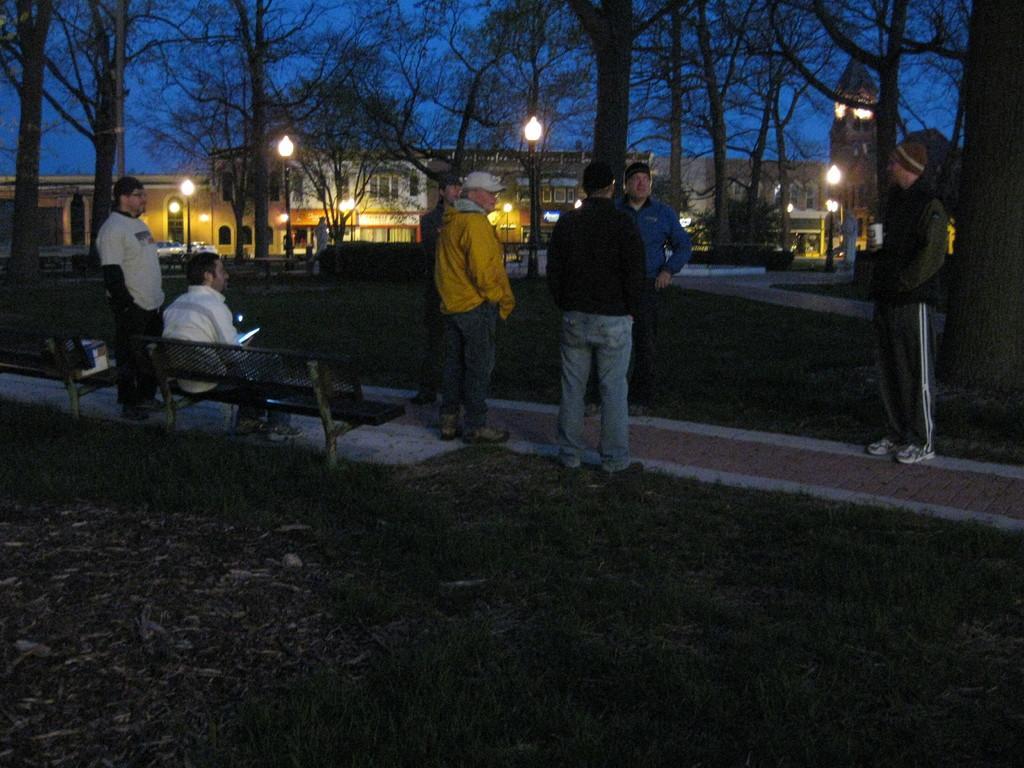Can you describe this image briefly? This is an image clicked in the dark. Here I can see few men are standing on the ground and one person is sitting on a bench. At the bottom, I can see the ground. In the background there are few light poles, trees and buildings. At the top of the image I can see the sky. 